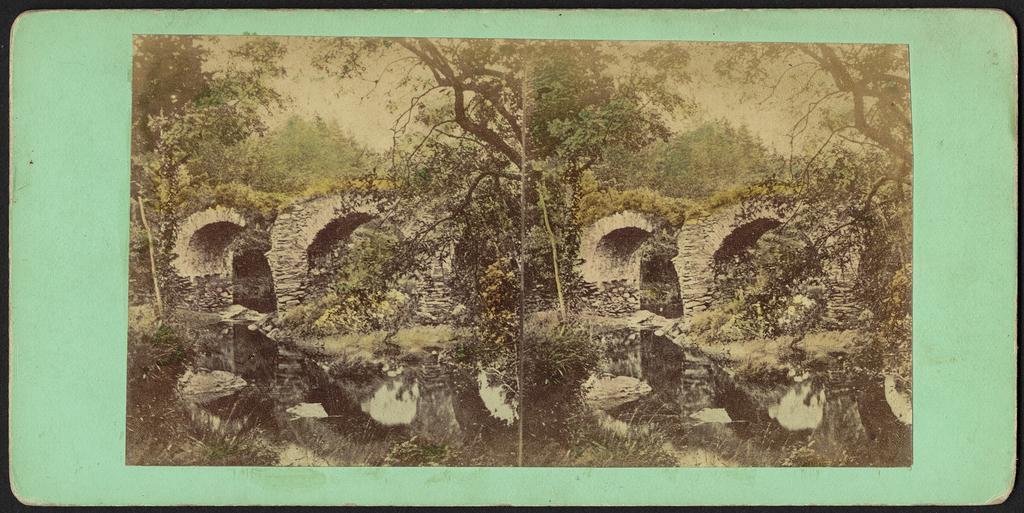Please provide a concise description of this image. This is a collage image. In this picture we can see the arches, trees, rocks. At the bottom of the image we can see the water, plants. At the top of the image we can see the sky. 